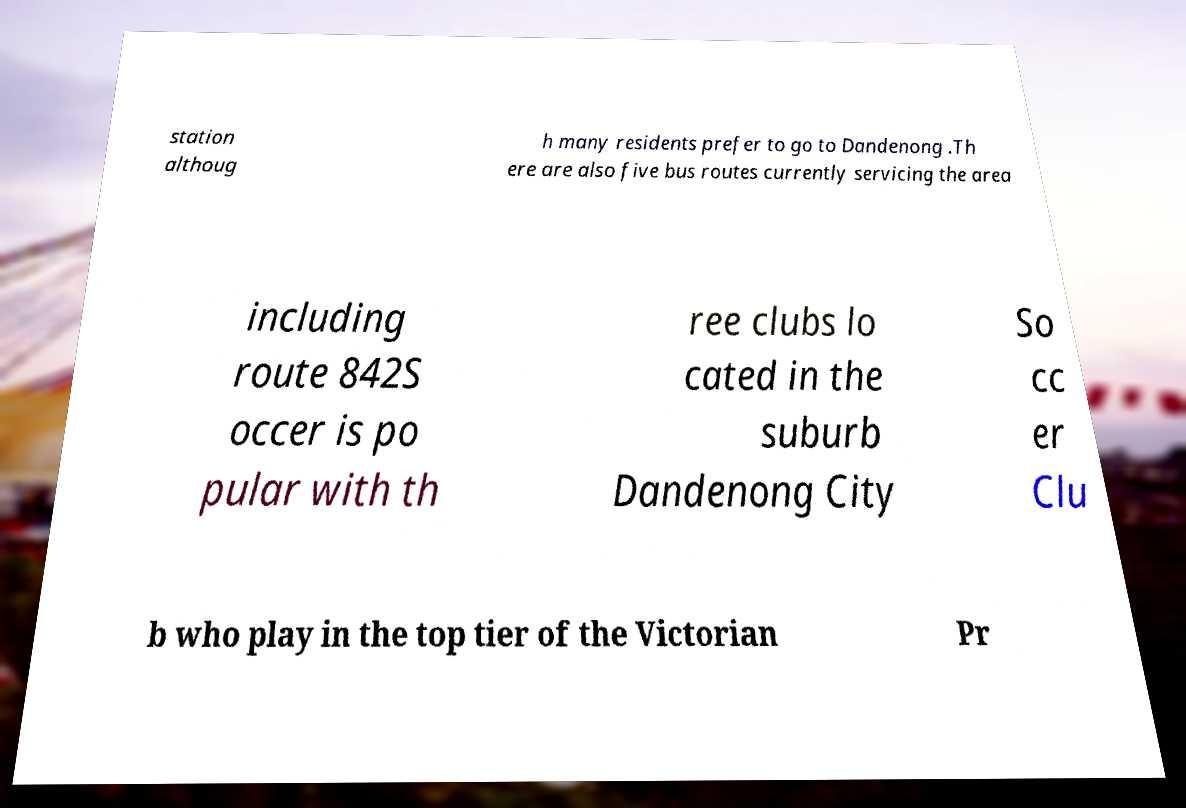Could you assist in decoding the text presented in this image and type it out clearly? station althoug h many residents prefer to go to Dandenong .Th ere are also five bus routes currently servicing the area including route 842S occer is po pular with th ree clubs lo cated in the suburb Dandenong City So cc er Clu b who play in the top tier of the Victorian Pr 